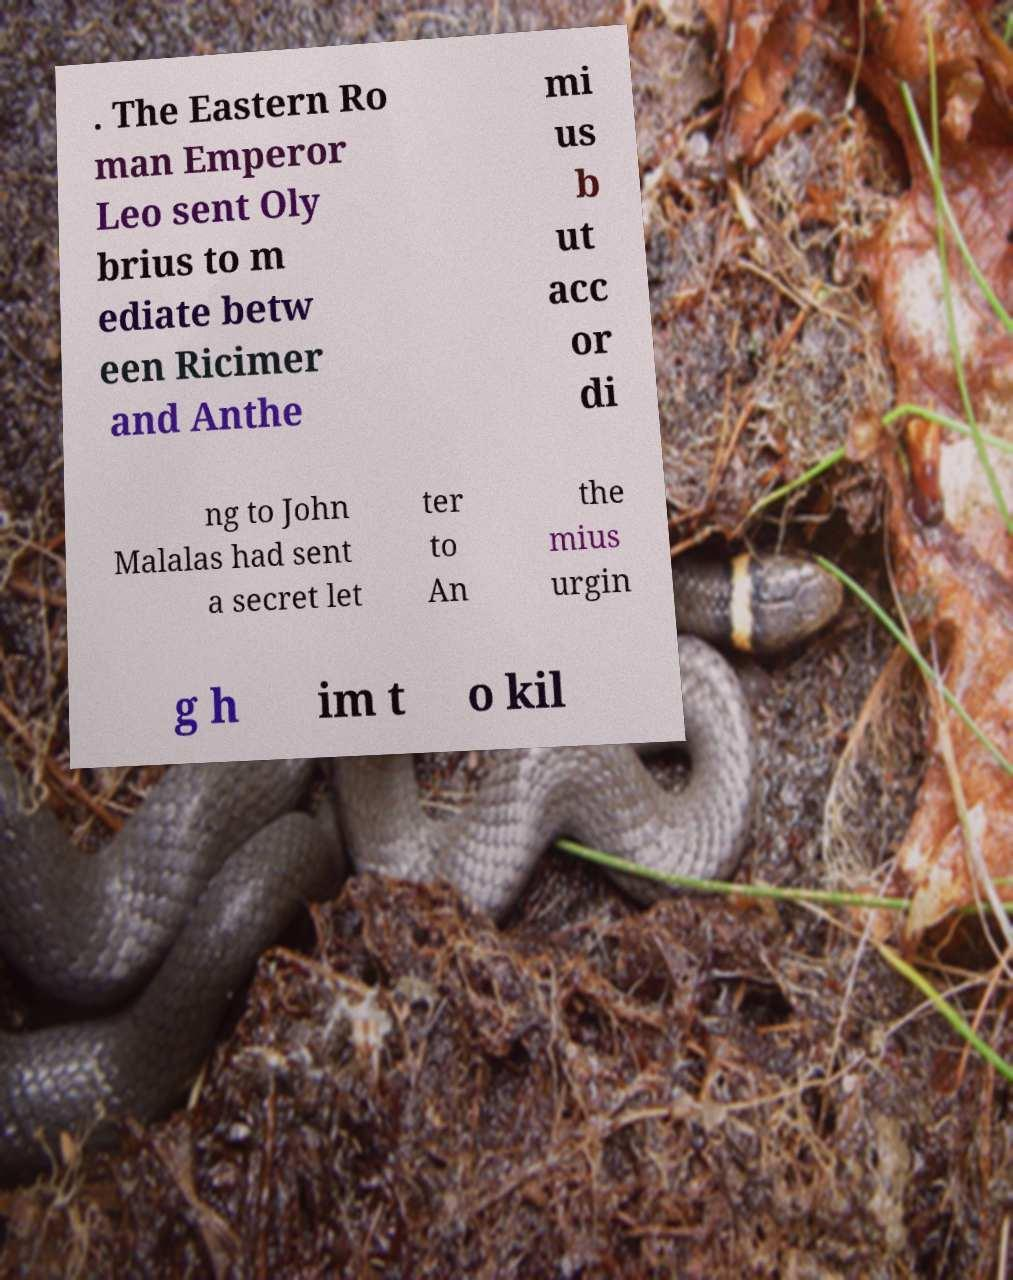Can you accurately transcribe the text from the provided image for me? . The Eastern Ro man Emperor Leo sent Oly brius to m ediate betw een Ricimer and Anthe mi us b ut acc or di ng to John Malalas had sent a secret let ter to An the mius urgin g h im t o kil 